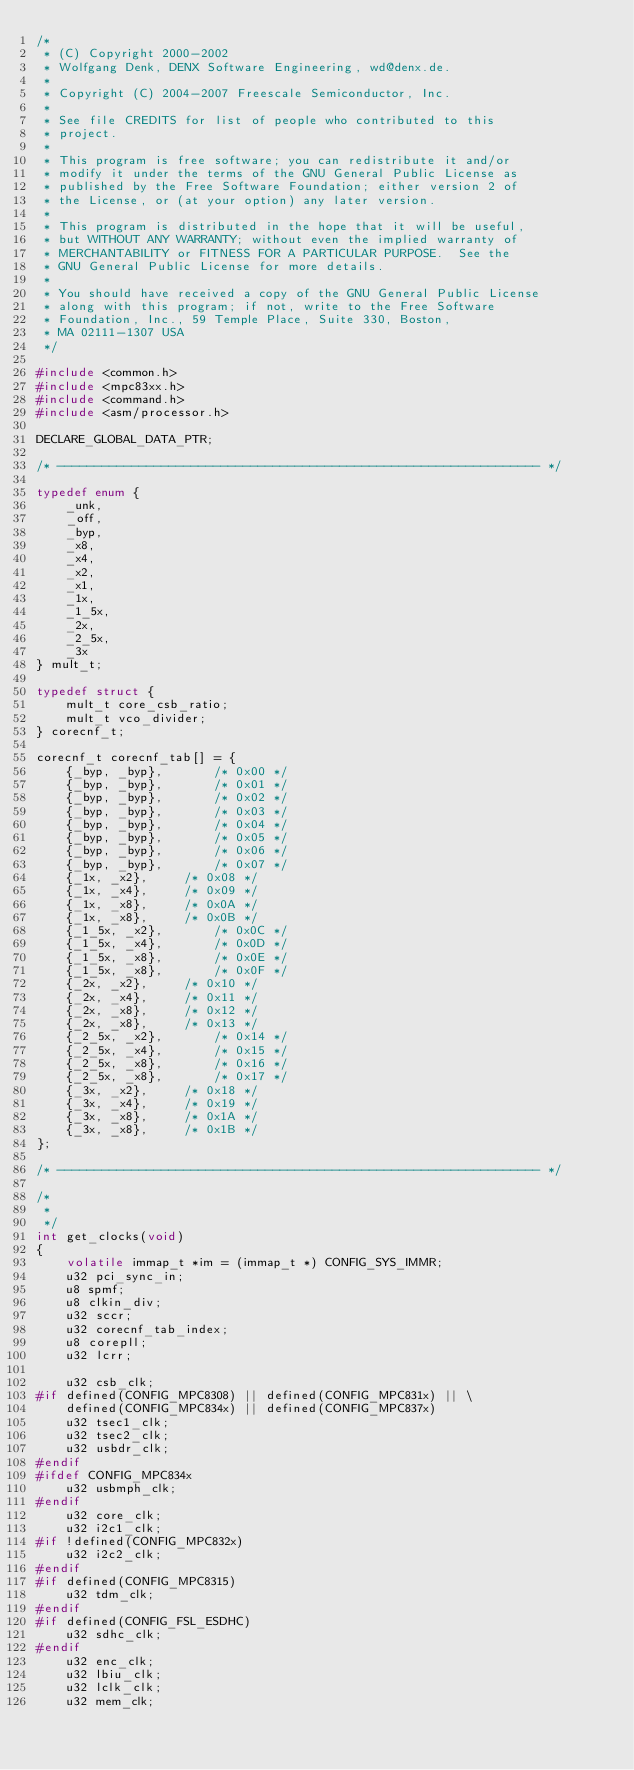Convert code to text. <code><loc_0><loc_0><loc_500><loc_500><_C_>/*
 * (C) Copyright 2000-2002
 * Wolfgang Denk, DENX Software Engineering, wd@denx.de.
 *
 * Copyright (C) 2004-2007 Freescale Semiconductor, Inc.
 *
 * See file CREDITS for list of people who contributed to this
 * project.
 *
 * This program is free software; you can redistribute it and/or
 * modify it under the terms of the GNU General Public License as
 * published by the Free Software Foundation; either version 2 of
 * the License, or (at your option) any later version.
 *
 * This program is distributed in the hope that it will be useful,
 * but WITHOUT ANY WARRANTY; without even the implied warranty of
 * MERCHANTABILITY or FITNESS FOR A PARTICULAR PURPOSE.  See the
 * GNU General Public License for more details.
 *
 * You should have received a copy of the GNU General Public License
 * along with this program; if not, write to the Free Software
 * Foundation, Inc., 59 Temple Place, Suite 330, Boston,
 * MA 02111-1307 USA
 */

#include <common.h>
#include <mpc83xx.h>
#include <command.h>
#include <asm/processor.h>

DECLARE_GLOBAL_DATA_PTR;

/* ----------------------------------------------------------------- */

typedef enum {
	_unk,
	_off,
	_byp,
	_x8,
	_x4,
	_x2,
	_x1,
	_1x,
	_1_5x,
	_2x,
	_2_5x,
	_3x
} mult_t;

typedef struct {
	mult_t core_csb_ratio;
	mult_t vco_divider;
} corecnf_t;

corecnf_t corecnf_tab[] = {
	{_byp, _byp},		/* 0x00 */
	{_byp, _byp},		/* 0x01 */
	{_byp, _byp},		/* 0x02 */
	{_byp, _byp},		/* 0x03 */
	{_byp, _byp},		/* 0x04 */
	{_byp, _byp},		/* 0x05 */
	{_byp, _byp},		/* 0x06 */
	{_byp, _byp},		/* 0x07 */
	{_1x, _x2},		/* 0x08 */
	{_1x, _x4},		/* 0x09 */
	{_1x, _x8},		/* 0x0A */
	{_1x, _x8},		/* 0x0B */
	{_1_5x, _x2},		/* 0x0C */
	{_1_5x, _x4},		/* 0x0D */
	{_1_5x, _x8},		/* 0x0E */
	{_1_5x, _x8},		/* 0x0F */
	{_2x, _x2},		/* 0x10 */
	{_2x, _x4},		/* 0x11 */
	{_2x, _x8},		/* 0x12 */
	{_2x, _x8},		/* 0x13 */
	{_2_5x, _x2},		/* 0x14 */
	{_2_5x, _x4},		/* 0x15 */
	{_2_5x, _x8},		/* 0x16 */
	{_2_5x, _x8},		/* 0x17 */
	{_3x, _x2},		/* 0x18 */
	{_3x, _x4},		/* 0x19 */
	{_3x, _x8},		/* 0x1A */
	{_3x, _x8},		/* 0x1B */
};

/* ----------------------------------------------------------------- */

/*
 *
 */
int get_clocks(void)
{
	volatile immap_t *im = (immap_t *) CONFIG_SYS_IMMR;
	u32 pci_sync_in;
	u8 spmf;
	u8 clkin_div;
	u32 sccr;
	u32 corecnf_tab_index;
	u8 corepll;
	u32 lcrr;

	u32 csb_clk;
#if defined(CONFIG_MPC8308) || defined(CONFIG_MPC831x) || \
	defined(CONFIG_MPC834x) || defined(CONFIG_MPC837x)
	u32 tsec1_clk;
	u32 tsec2_clk;
	u32 usbdr_clk;
#endif
#ifdef CONFIG_MPC834x
	u32 usbmph_clk;
#endif
	u32 core_clk;
	u32 i2c1_clk;
#if !defined(CONFIG_MPC832x)
	u32 i2c2_clk;
#endif
#if defined(CONFIG_MPC8315)
	u32 tdm_clk;
#endif
#if defined(CONFIG_FSL_ESDHC)
	u32 sdhc_clk;
#endif
	u32 enc_clk;
	u32 lbiu_clk;
	u32 lclk_clk;
	u32 mem_clk;</code> 